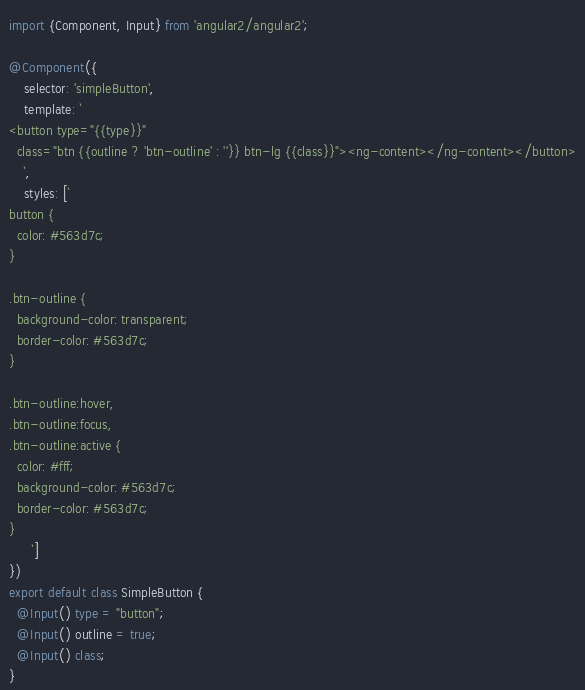Convert code to text. <code><loc_0><loc_0><loc_500><loc_500><_TypeScript_>import {Component, Input} from 'angular2/angular2';

@Component({
    selector: 'simpleButton',
    template: `
<button type="{{type}}"
  class="btn {{outline ? 'btn-outline' : ''}} btn-lg {{class}}"><ng-content></ng-content></button>
    `,
    styles: [`
button {
  color: #563d7c;
}

.btn-outline {
  background-color: transparent;
  border-color: #563d7c;
}

.btn-outline:hover,
.btn-outline:focus,
.btn-outline:active {
  color: #fff;
  background-color: #563d7c;
  border-color: #563d7c;
}
      `]
})
export default class SimpleButton {
  @Input() type = "button";
  @Input() outline = true;
  @Input() class;
}
</code> 